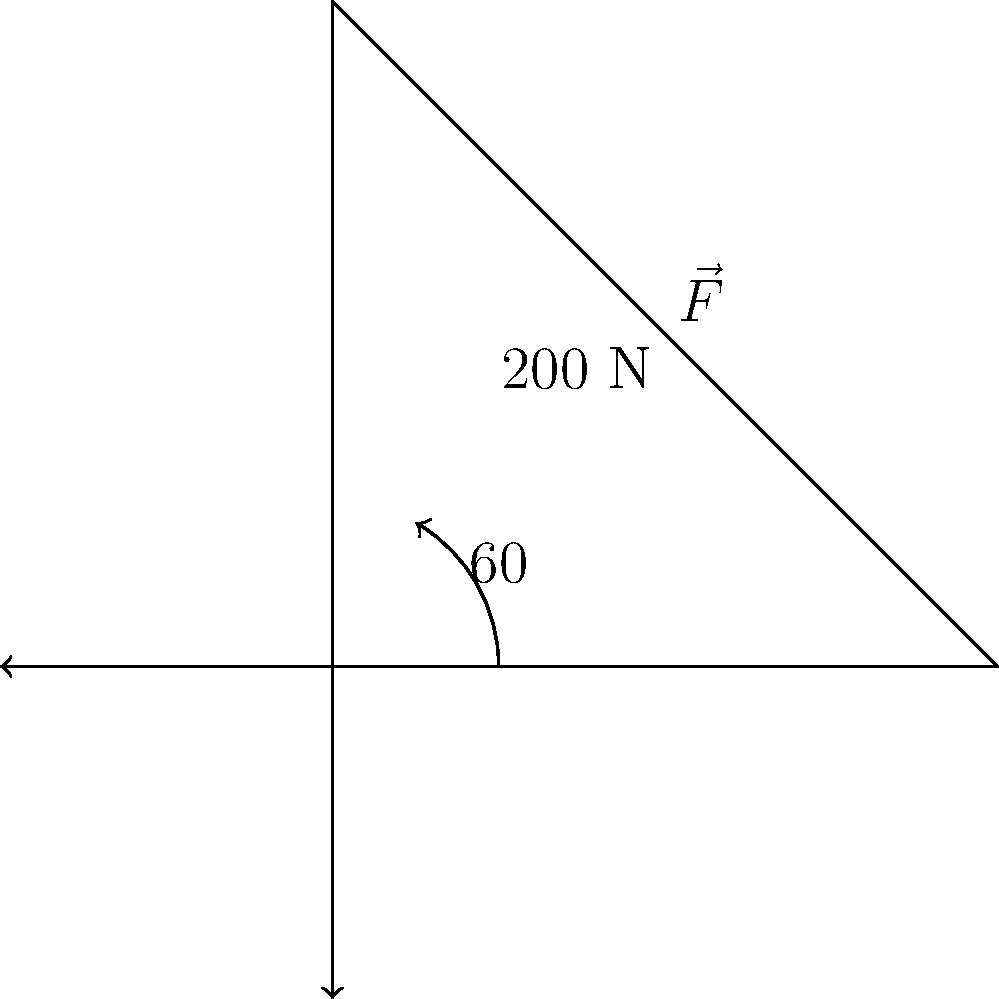During a patient transfer, a nurse applies a force $\vec{F}$ of 200 N at an angle of 60° above the horizontal. Calculate the horizontal component of this force that contributes to moving the patient laterally. To solve this problem, we need to follow these steps:

1) The horizontal component of a force is given by the cosine of the angle multiplied by the magnitude of the force.

2) In this case, we're looking for $F_x = F \cos \theta$, where:
   - $F$ is the magnitude of the force (200 N)
   - $\theta$ is the angle above the horizontal (60°)

3) Plugging in the values:

   $F_x = 200 \cos 60°$

4) $\cos 60° = 0.5$

5) Therefore:
   
   $F_x = 200 \cdot 0.5 = 100$ N

The horizontal component of the force is 100 N, which is the force contributing to moving the patient laterally.
Answer: 100 N 